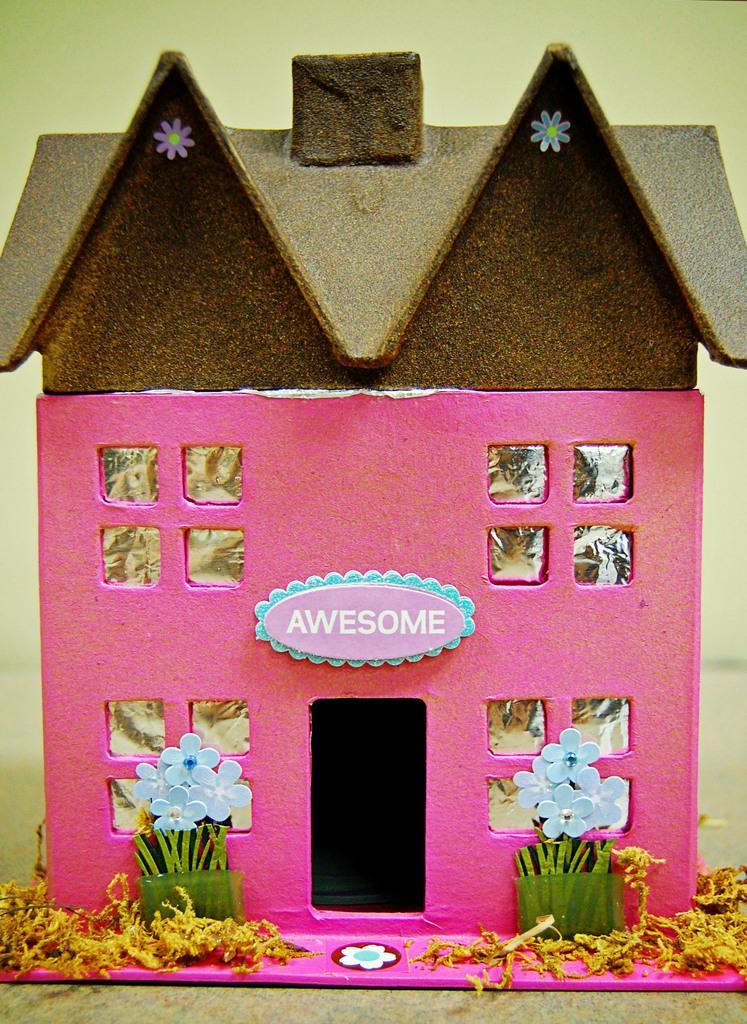In one or two sentences, can you explain what this image depicts? In this picture, we see a toy house or a building. It is in pink color and the roof of the building is in brown color. Beside that, we see the flower pots. In the background, we see a wall. 